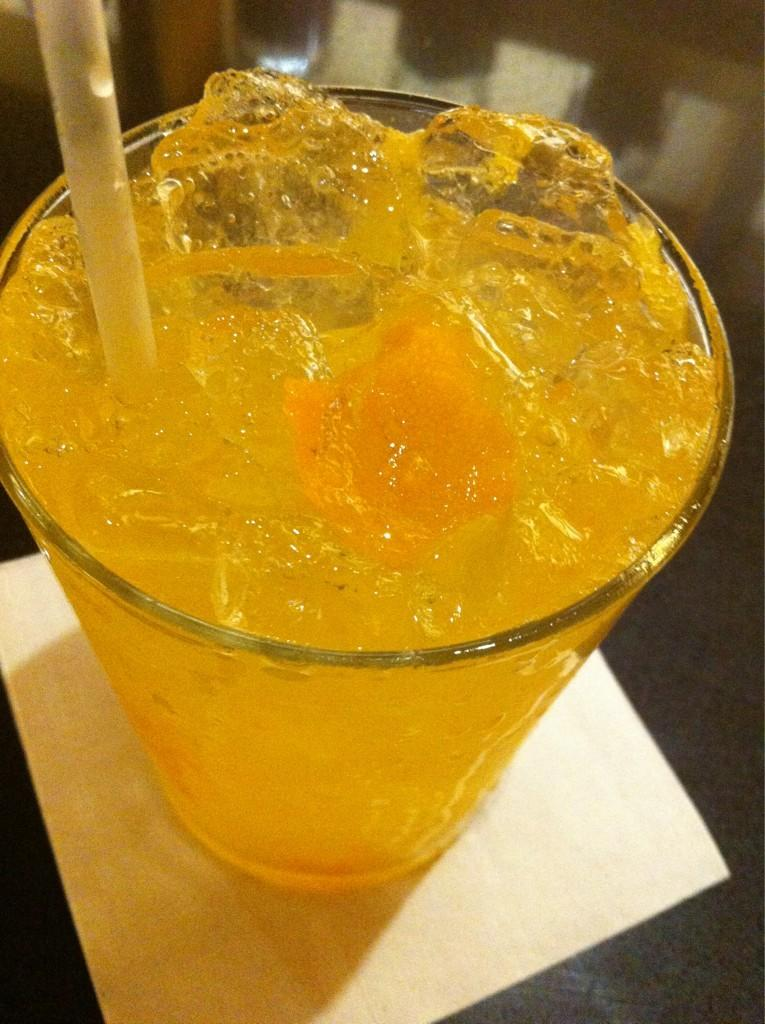What is in the glass that is visible in the image? There is a drink in the image. What can be seen inside the drink? There are ice cubes in the drink. How might someone consume the drink? There is a straw in the glass, which can be used to drink the liquid. What object is present on the table in the image? There appears to be a tissue on the table. What type of thrill can be experienced from the account in the image? There is no account or thrill present in the image; it features a glass with a drink, ice cubes, and a straw. 